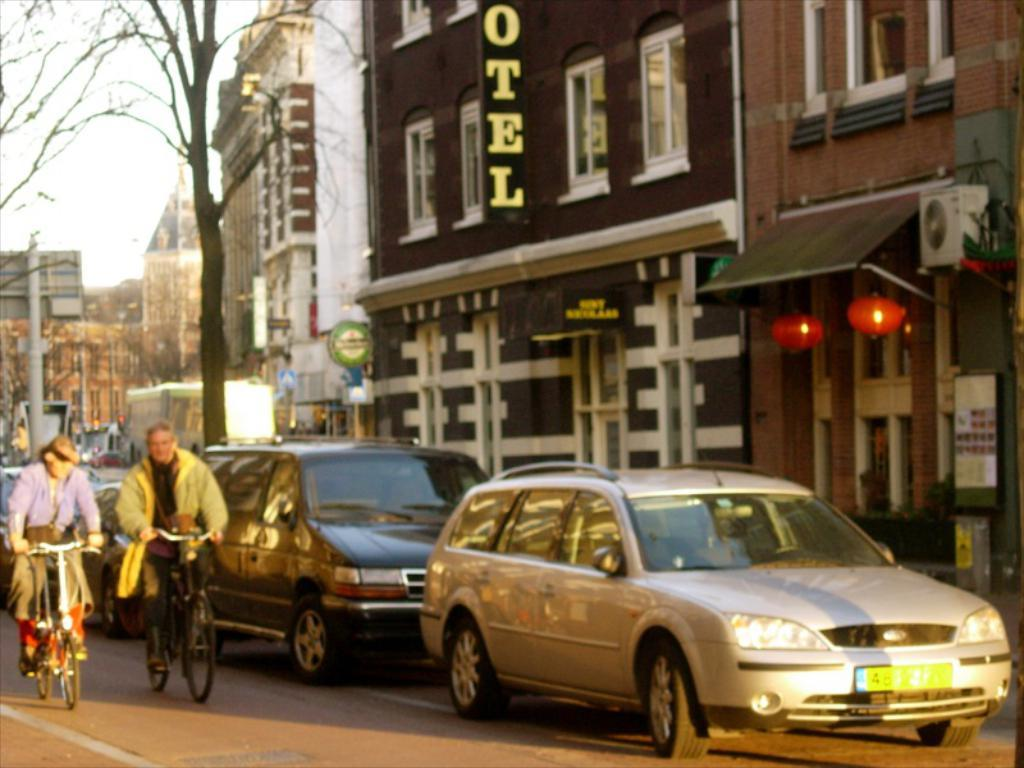<image>
Write a terse but informative summary of the picture. Two people cycle passed a parked car in the street with a yellow license plate beginning with the number 4. 